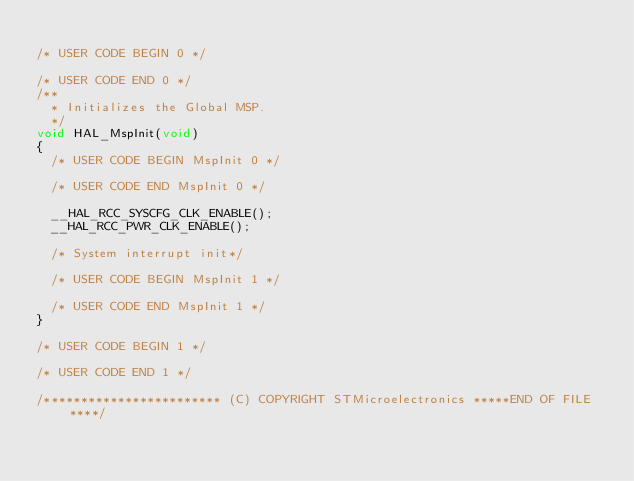Convert code to text. <code><loc_0><loc_0><loc_500><loc_500><_C_>
/* USER CODE BEGIN 0 */

/* USER CODE END 0 */
/**
  * Initializes the Global MSP.
  */
void HAL_MspInit(void)
{
  /* USER CODE BEGIN MspInit 0 */

  /* USER CODE END MspInit 0 */

  __HAL_RCC_SYSCFG_CLK_ENABLE();
  __HAL_RCC_PWR_CLK_ENABLE();

  /* System interrupt init*/

  /* USER CODE BEGIN MspInit 1 */

  /* USER CODE END MspInit 1 */
}

/* USER CODE BEGIN 1 */

/* USER CODE END 1 */

/************************ (C) COPYRIGHT STMicroelectronics *****END OF FILE****/
</code> 